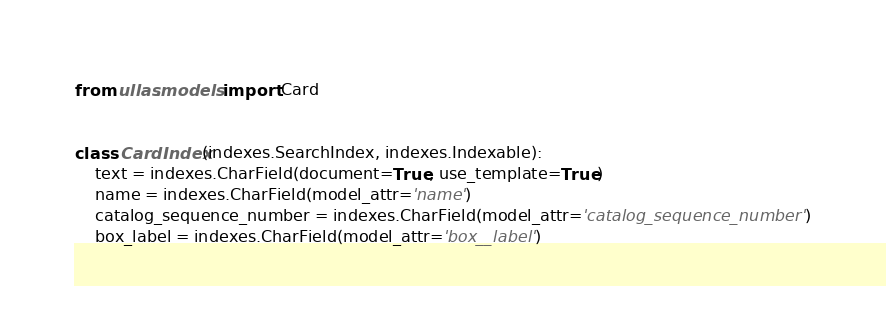<code> <loc_0><loc_0><loc_500><loc_500><_Python_>from ullas.models import Card


class CardIndex(indexes.SearchIndex, indexes.Indexable):
    text = indexes.CharField(document=True, use_template=True)
    name = indexes.CharField(model_attr='name')
    catalog_sequence_number = indexes.CharField(model_attr='catalog_sequence_number')
    box_label = indexes.CharField(model_attr='box__label')</code> 